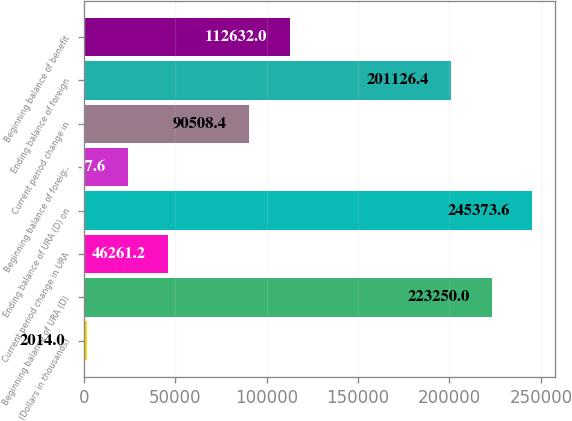Convert chart to OTSL. <chart><loc_0><loc_0><loc_500><loc_500><bar_chart><fcel>(Dollars in thousands)<fcel>Beginning balance of URA (D)<fcel>Current period change in URA<fcel>Ending balance of URA (D) on<fcel>Beginning balance of foreign<fcel>Current period change in<fcel>Ending balance of foreign<fcel>Beginning balance of benefit<nl><fcel>2014<fcel>223250<fcel>46261.2<fcel>245374<fcel>24137.6<fcel>90508.4<fcel>201126<fcel>112632<nl></chart> 